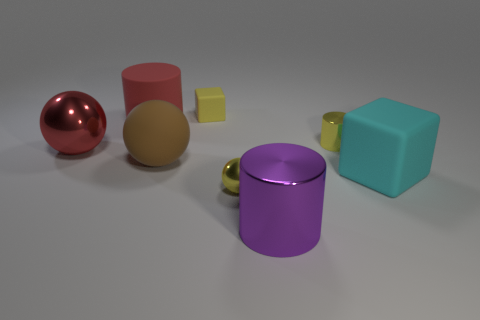How many red spheres are left of the cube that is in front of the large brown object that is on the left side of the small yellow sphere?
Your answer should be compact. 1. There is a big rubber ball; does it have the same color as the object behind the matte cylinder?
Ensure brevity in your answer.  No. What size is the yellow object that is made of the same material as the brown sphere?
Your answer should be very brief. Small. Are there more cyan things that are behind the yellow matte block than matte blocks?
Provide a short and direct response. No. There is a brown sphere to the left of the big object that is on the right side of the large shiny object that is in front of the red metallic ball; what is it made of?
Offer a terse response. Rubber. Are the brown thing and the ball on the left side of the brown matte thing made of the same material?
Offer a very short reply. No. What is the material of the other object that is the same shape as the yellow matte thing?
Your response must be concise. Rubber. Is there anything else that has the same material as the large red ball?
Give a very brief answer. Yes. Is the number of large cyan matte blocks that are left of the small yellow metallic cylinder greater than the number of yellow metal things on the left side of the tiny cube?
Your answer should be very brief. No. There is a cyan thing that is the same material as the big brown object; what is its shape?
Your answer should be very brief. Cube. 